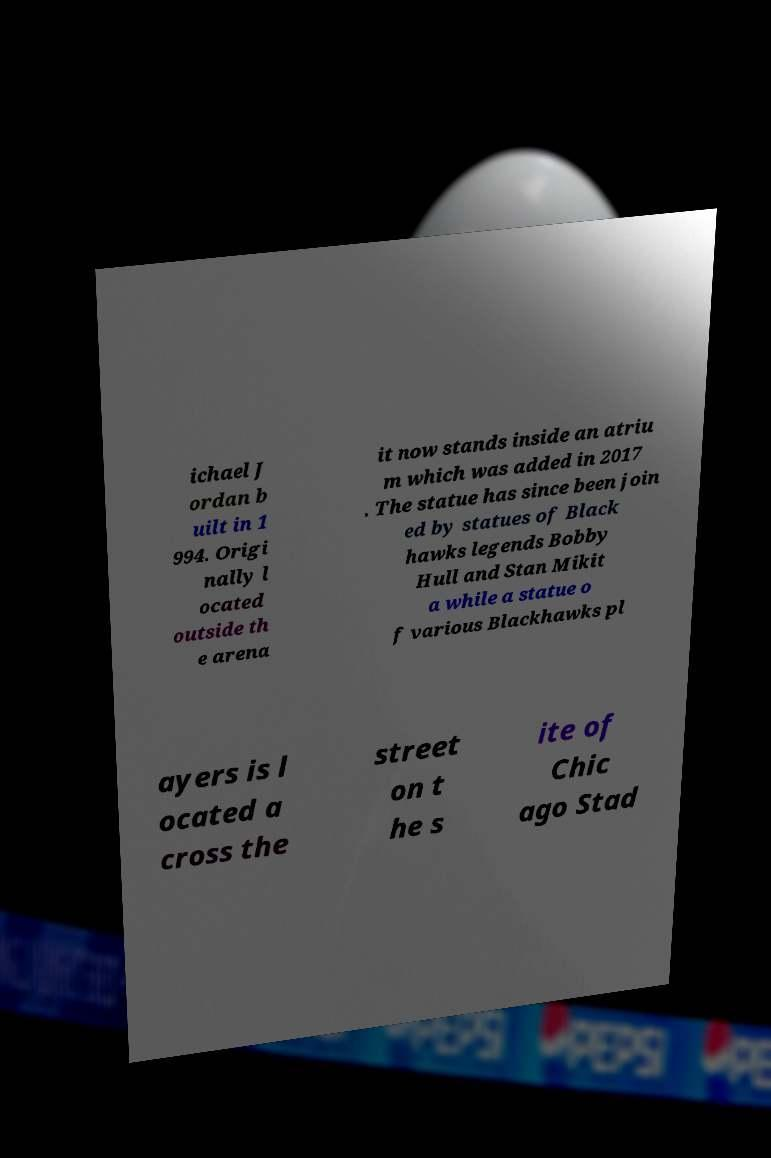Please read and relay the text visible in this image. What does it say? ichael J ordan b uilt in 1 994. Origi nally l ocated outside th e arena it now stands inside an atriu m which was added in 2017 . The statue has since been join ed by statues of Black hawks legends Bobby Hull and Stan Mikit a while a statue o f various Blackhawks pl ayers is l ocated a cross the street on t he s ite of Chic ago Stad 